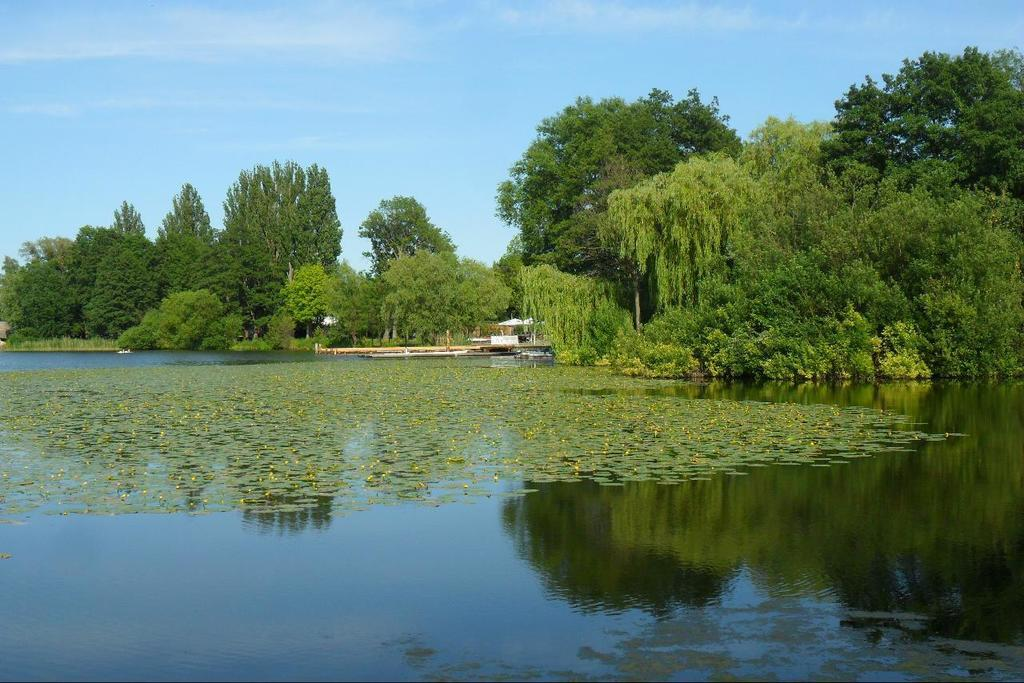What is the primary element in the image? The image consists of water. What can be seen in the background of the image? There are many trees and plants in the background. What is visible at the top of the image? The sky is visible at the top of the image. Where is the sink located in the image? There is no sink present in the image; it consists of water, trees and plants, and the sky. 